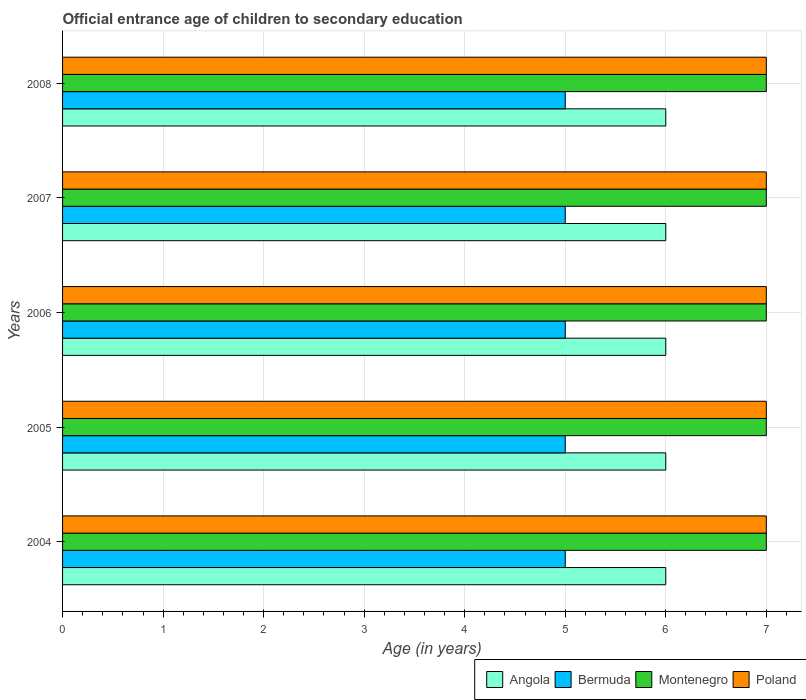Are the number of bars per tick equal to the number of legend labels?
Make the answer very short. Yes. How many bars are there on the 2nd tick from the top?
Make the answer very short. 4. What is the label of the 3rd group of bars from the top?
Make the answer very short. 2006. In how many cases, is the number of bars for a given year not equal to the number of legend labels?
Give a very brief answer. 0. What is the secondary school starting age of children in Poland in 2008?
Make the answer very short. 7. Across all years, what is the maximum secondary school starting age of children in Bermuda?
Offer a terse response. 5. Across all years, what is the minimum secondary school starting age of children in Bermuda?
Provide a short and direct response. 5. What is the total secondary school starting age of children in Montenegro in the graph?
Your response must be concise. 35. What is the difference between the secondary school starting age of children in Angola in 2004 and that in 2007?
Keep it short and to the point. 0. What is the difference between the secondary school starting age of children in Bermuda in 2006 and the secondary school starting age of children in Montenegro in 2005?
Your response must be concise. -2. In the year 2006, what is the difference between the secondary school starting age of children in Poland and secondary school starting age of children in Montenegro?
Keep it short and to the point. 0. Is the secondary school starting age of children in Angola in 2004 less than that in 2007?
Offer a very short reply. No. Is the difference between the secondary school starting age of children in Poland in 2004 and 2008 greater than the difference between the secondary school starting age of children in Montenegro in 2004 and 2008?
Your answer should be very brief. No. What is the difference between the highest and the second highest secondary school starting age of children in Montenegro?
Keep it short and to the point. 0. In how many years, is the secondary school starting age of children in Bermuda greater than the average secondary school starting age of children in Bermuda taken over all years?
Keep it short and to the point. 0. Is the sum of the secondary school starting age of children in Poland in 2006 and 2008 greater than the maximum secondary school starting age of children in Angola across all years?
Give a very brief answer. Yes. What does the 3rd bar from the bottom in 2008 represents?
Your answer should be very brief. Montenegro. How many bars are there?
Your response must be concise. 20. Are all the bars in the graph horizontal?
Provide a short and direct response. Yes. How many years are there in the graph?
Ensure brevity in your answer.  5. Does the graph contain any zero values?
Offer a very short reply. No. How many legend labels are there?
Provide a short and direct response. 4. How are the legend labels stacked?
Make the answer very short. Horizontal. What is the title of the graph?
Your answer should be compact. Official entrance age of children to secondary education. What is the label or title of the X-axis?
Your response must be concise. Age (in years). What is the label or title of the Y-axis?
Provide a succinct answer. Years. What is the Age (in years) of Montenegro in 2004?
Provide a short and direct response. 7. What is the Age (in years) of Poland in 2004?
Your answer should be compact. 7. What is the Age (in years) of Angola in 2005?
Provide a short and direct response. 6. What is the Age (in years) in Bermuda in 2006?
Keep it short and to the point. 5. What is the Age (in years) of Poland in 2006?
Your answer should be very brief. 7. What is the Age (in years) of Poland in 2007?
Offer a very short reply. 7. What is the Age (in years) of Montenegro in 2008?
Give a very brief answer. 7. What is the Age (in years) of Poland in 2008?
Offer a very short reply. 7. Across all years, what is the minimum Age (in years) in Angola?
Ensure brevity in your answer.  6. Across all years, what is the minimum Age (in years) in Bermuda?
Keep it short and to the point. 5. What is the total Age (in years) of Bermuda in the graph?
Ensure brevity in your answer.  25. What is the total Age (in years) of Poland in the graph?
Give a very brief answer. 35. What is the difference between the Age (in years) in Montenegro in 2004 and that in 2005?
Give a very brief answer. 0. What is the difference between the Age (in years) of Angola in 2004 and that in 2008?
Ensure brevity in your answer.  0. What is the difference between the Age (in years) of Bermuda in 2004 and that in 2008?
Offer a terse response. 0. What is the difference between the Age (in years) of Montenegro in 2005 and that in 2006?
Give a very brief answer. 0. What is the difference between the Age (in years) of Bermuda in 2005 and that in 2007?
Keep it short and to the point. 0. What is the difference between the Age (in years) of Montenegro in 2005 and that in 2007?
Give a very brief answer. 0. What is the difference between the Age (in years) of Poland in 2005 and that in 2007?
Make the answer very short. 0. What is the difference between the Age (in years) of Angola in 2005 and that in 2008?
Offer a very short reply. 0. What is the difference between the Age (in years) of Montenegro in 2005 and that in 2008?
Ensure brevity in your answer.  0. What is the difference between the Age (in years) in Poland in 2005 and that in 2008?
Keep it short and to the point. 0. What is the difference between the Age (in years) of Angola in 2006 and that in 2007?
Your answer should be very brief. 0. What is the difference between the Age (in years) in Bermuda in 2006 and that in 2007?
Your response must be concise. 0. What is the difference between the Age (in years) in Montenegro in 2006 and that in 2007?
Provide a succinct answer. 0. What is the difference between the Age (in years) of Poland in 2006 and that in 2007?
Give a very brief answer. 0. What is the difference between the Age (in years) in Angola in 2006 and that in 2008?
Your response must be concise. 0. What is the difference between the Age (in years) in Montenegro in 2006 and that in 2008?
Ensure brevity in your answer.  0. What is the difference between the Age (in years) of Angola in 2007 and that in 2008?
Your answer should be compact. 0. What is the difference between the Age (in years) of Bermuda in 2007 and that in 2008?
Provide a succinct answer. 0. What is the difference between the Age (in years) in Montenegro in 2007 and that in 2008?
Keep it short and to the point. 0. What is the difference between the Age (in years) in Poland in 2007 and that in 2008?
Offer a very short reply. 0. What is the difference between the Age (in years) of Angola in 2004 and the Age (in years) of Montenegro in 2005?
Ensure brevity in your answer.  -1. What is the difference between the Age (in years) in Angola in 2004 and the Age (in years) in Poland in 2005?
Keep it short and to the point. -1. What is the difference between the Age (in years) in Angola in 2004 and the Age (in years) in Bermuda in 2006?
Ensure brevity in your answer.  1. What is the difference between the Age (in years) in Angola in 2004 and the Age (in years) in Montenegro in 2006?
Your answer should be compact. -1. What is the difference between the Age (in years) of Bermuda in 2004 and the Age (in years) of Montenegro in 2006?
Ensure brevity in your answer.  -2. What is the difference between the Age (in years) of Angola in 2004 and the Age (in years) of Bermuda in 2007?
Keep it short and to the point. 1. What is the difference between the Age (in years) in Angola in 2004 and the Age (in years) in Montenegro in 2007?
Your answer should be compact. -1. What is the difference between the Age (in years) of Angola in 2004 and the Age (in years) of Poland in 2007?
Provide a short and direct response. -1. What is the difference between the Age (in years) of Bermuda in 2004 and the Age (in years) of Montenegro in 2007?
Offer a terse response. -2. What is the difference between the Age (in years) of Bermuda in 2004 and the Age (in years) of Poland in 2007?
Offer a terse response. -2. What is the difference between the Age (in years) in Angola in 2004 and the Age (in years) in Montenegro in 2008?
Your response must be concise. -1. What is the difference between the Age (in years) of Montenegro in 2004 and the Age (in years) of Poland in 2008?
Your answer should be very brief. 0. What is the difference between the Age (in years) of Angola in 2005 and the Age (in years) of Montenegro in 2006?
Give a very brief answer. -1. What is the difference between the Age (in years) of Bermuda in 2005 and the Age (in years) of Montenegro in 2006?
Provide a succinct answer. -2. What is the difference between the Age (in years) in Angola in 2005 and the Age (in years) in Poland in 2007?
Keep it short and to the point. -1. What is the difference between the Age (in years) in Bermuda in 2005 and the Age (in years) in Montenegro in 2007?
Your response must be concise. -2. What is the difference between the Age (in years) of Bermuda in 2005 and the Age (in years) of Poland in 2007?
Provide a short and direct response. -2. What is the difference between the Age (in years) in Montenegro in 2005 and the Age (in years) in Poland in 2007?
Make the answer very short. 0. What is the difference between the Age (in years) of Angola in 2005 and the Age (in years) of Bermuda in 2008?
Your answer should be very brief. 1. What is the difference between the Age (in years) of Angola in 2005 and the Age (in years) of Montenegro in 2008?
Your response must be concise. -1. What is the difference between the Age (in years) in Angola in 2006 and the Age (in years) in Bermuda in 2007?
Make the answer very short. 1. What is the difference between the Age (in years) in Angola in 2006 and the Age (in years) in Montenegro in 2007?
Offer a very short reply. -1. What is the difference between the Age (in years) of Bermuda in 2006 and the Age (in years) of Montenegro in 2007?
Offer a very short reply. -2. What is the difference between the Age (in years) in Montenegro in 2006 and the Age (in years) in Poland in 2007?
Keep it short and to the point. 0. What is the difference between the Age (in years) of Angola in 2006 and the Age (in years) of Bermuda in 2008?
Offer a very short reply. 1. What is the difference between the Age (in years) in Angola in 2006 and the Age (in years) in Montenegro in 2008?
Ensure brevity in your answer.  -1. What is the difference between the Age (in years) of Bermuda in 2006 and the Age (in years) of Montenegro in 2008?
Ensure brevity in your answer.  -2. What is the difference between the Age (in years) of Bermuda in 2006 and the Age (in years) of Poland in 2008?
Your answer should be very brief. -2. What is the difference between the Age (in years) in Angola in 2007 and the Age (in years) in Bermuda in 2008?
Provide a short and direct response. 1. What is the difference between the Age (in years) in Angola in 2007 and the Age (in years) in Montenegro in 2008?
Make the answer very short. -1. What is the difference between the Age (in years) in Bermuda in 2007 and the Age (in years) in Montenegro in 2008?
Your answer should be very brief. -2. What is the difference between the Age (in years) of Montenegro in 2007 and the Age (in years) of Poland in 2008?
Offer a terse response. 0. What is the average Age (in years) in Angola per year?
Make the answer very short. 6. What is the average Age (in years) of Bermuda per year?
Provide a succinct answer. 5. In the year 2004, what is the difference between the Age (in years) in Bermuda and Age (in years) in Poland?
Provide a succinct answer. -2. In the year 2004, what is the difference between the Age (in years) of Montenegro and Age (in years) of Poland?
Your answer should be compact. 0. In the year 2005, what is the difference between the Age (in years) of Angola and Age (in years) of Montenegro?
Provide a succinct answer. -1. In the year 2005, what is the difference between the Age (in years) in Bermuda and Age (in years) in Montenegro?
Ensure brevity in your answer.  -2. In the year 2005, what is the difference between the Age (in years) in Bermuda and Age (in years) in Poland?
Offer a terse response. -2. In the year 2005, what is the difference between the Age (in years) in Montenegro and Age (in years) in Poland?
Make the answer very short. 0. In the year 2006, what is the difference between the Age (in years) of Angola and Age (in years) of Bermuda?
Provide a succinct answer. 1. In the year 2006, what is the difference between the Age (in years) of Angola and Age (in years) of Poland?
Offer a terse response. -1. In the year 2006, what is the difference between the Age (in years) of Bermuda and Age (in years) of Montenegro?
Your answer should be very brief. -2. In the year 2006, what is the difference between the Age (in years) in Montenegro and Age (in years) in Poland?
Your response must be concise. 0. In the year 2007, what is the difference between the Age (in years) in Angola and Age (in years) in Bermuda?
Your answer should be compact. 1. In the year 2007, what is the difference between the Age (in years) of Angola and Age (in years) of Montenegro?
Offer a very short reply. -1. In the year 2007, what is the difference between the Age (in years) of Bermuda and Age (in years) of Poland?
Make the answer very short. -2. In the year 2007, what is the difference between the Age (in years) in Montenegro and Age (in years) in Poland?
Your answer should be compact. 0. In the year 2008, what is the difference between the Age (in years) of Bermuda and Age (in years) of Montenegro?
Offer a terse response. -2. In the year 2008, what is the difference between the Age (in years) of Bermuda and Age (in years) of Poland?
Offer a very short reply. -2. What is the ratio of the Age (in years) in Bermuda in 2004 to that in 2005?
Provide a succinct answer. 1. What is the ratio of the Age (in years) in Montenegro in 2004 to that in 2005?
Provide a short and direct response. 1. What is the ratio of the Age (in years) of Poland in 2004 to that in 2005?
Your response must be concise. 1. What is the ratio of the Age (in years) of Montenegro in 2004 to that in 2006?
Your answer should be very brief. 1. What is the ratio of the Age (in years) of Poland in 2004 to that in 2006?
Give a very brief answer. 1. What is the ratio of the Age (in years) in Angola in 2004 to that in 2007?
Make the answer very short. 1. What is the ratio of the Age (in years) of Bermuda in 2004 to that in 2007?
Your answer should be very brief. 1. What is the ratio of the Age (in years) in Bermuda in 2004 to that in 2008?
Provide a short and direct response. 1. What is the ratio of the Age (in years) in Poland in 2004 to that in 2008?
Your answer should be compact. 1. What is the ratio of the Age (in years) of Poland in 2005 to that in 2006?
Offer a terse response. 1. What is the ratio of the Age (in years) of Angola in 2005 to that in 2007?
Make the answer very short. 1. What is the ratio of the Age (in years) of Bermuda in 2005 to that in 2008?
Your response must be concise. 1. What is the ratio of the Age (in years) of Montenegro in 2005 to that in 2008?
Keep it short and to the point. 1. What is the ratio of the Age (in years) of Angola in 2006 to that in 2007?
Make the answer very short. 1. What is the ratio of the Age (in years) in Bermuda in 2006 to that in 2007?
Offer a very short reply. 1. What is the ratio of the Age (in years) in Montenegro in 2006 to that in 2007?
Make the answer very short. 1. What is the ratio of the Age (in years) of Montenegro in 2006 to that in 2008?
Your answer should be very brief. 1. What is the ratio of the Age (in years) of Angola in 2007 to that in 2008?
Your answer should be very brief. 1. What is the ratio of the Age (in years) of Poland in 2007 to that in 2008?
Provide a succinct answer. 1. What is the difference between the highest and the second highest Age (in years) of Angola?
Your answer should be compact. 0. What is the difference between the highest and the second highest Age (in years) in Bermuda?
Give a very brief answer. 0. What is the difference between the highest and the second highest Age (in years) of Montenegro?
Provide a succinct answer. 0. 